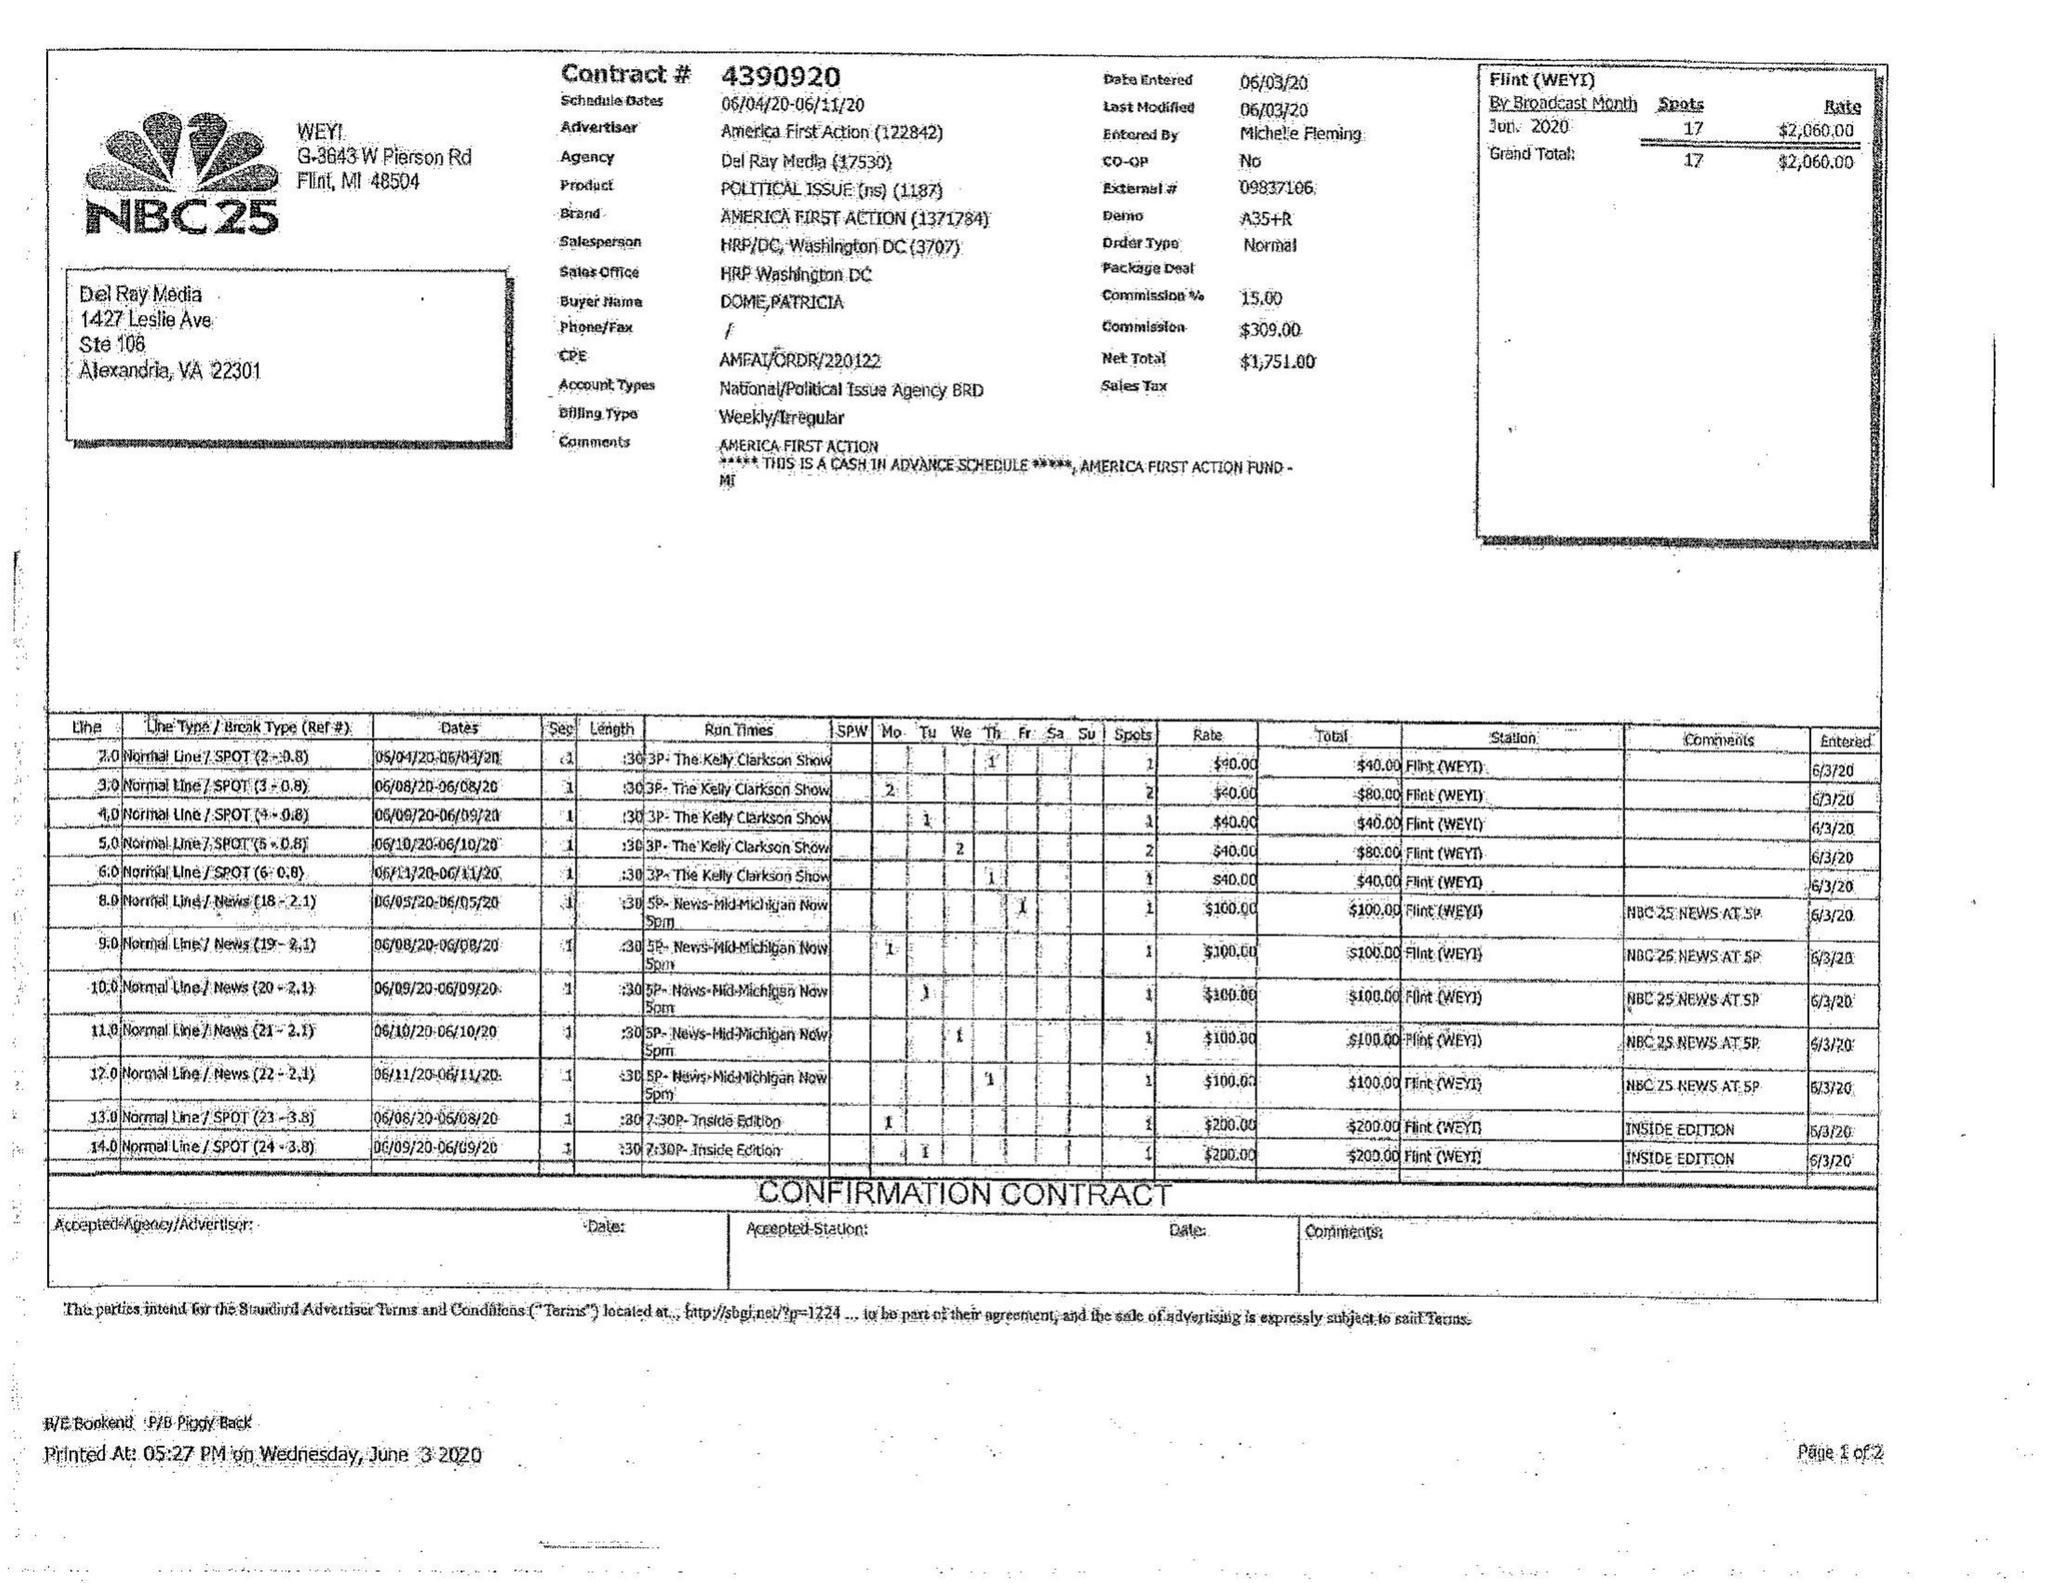What is the value for the contract_num?
Answer the question using a single word or phrase. 4390920 